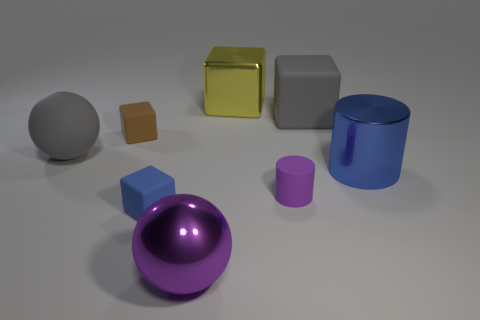Subtract all big shiny blocks. How many blocks are left? 3 Subtract all blue cubes. How many cubes are left? 3 Add 1 cylinders. How many objects exist? 9 Subtract all balls. How many objects are left? 6 Subtract 3 cubes. How many cubes are left? 1 Subtract all cyan cylinders. How many red cubes are left? 0 Subtract all big matte things. Subtract all yellow shiny cubes. How many objects are left? 5 Add 3 blue things. How many blue things are left? 5 Add 7 tiny blue spheres. How many tiny blue spheres exist? 7 Subtract 0 brown cylinders. How many objects are left? 8 